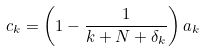<formula> <loc_0><loc_0><loc_500><loc_500>c _ { k } = \left ( 1 - \frac { 1 } { k + N + \delta _ { k } } \right ) a _ { k }</formula> 